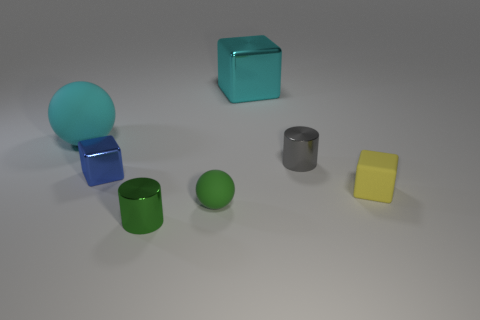Add 2 large green rubber blocks. How many objects exist? 9 Subtract all small blocks. How many blocks are left? 1 Subtract all yellow cubes. How many cubes are left? 2 Subtract 0 yellow balls. How many objects are left? 7 Subtract all cubes. How many objects are left? 4 Subtract 1 cubes. How many cubes are left? 2 Subtract all green cylinders. Subtract all purple balls. How many cylinders are left? 1 Subtract all cyan cubes. How many gray cylinders are left? 1 Subtract all tiny shiny cubes. Subtract all small green spheres. How many objects are left? 5 Add 3 small blue metal blocks. How many small blue metal blocks are left? 4 